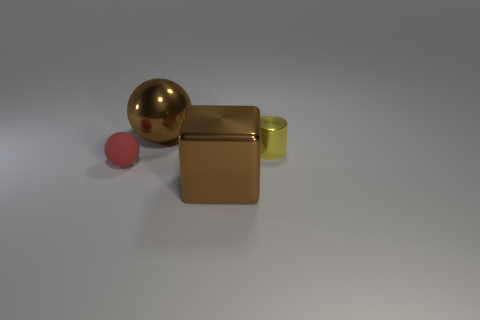What number of other objects are there of the same size as the red matte ball?
Provide a succinct answer. 1. What material is the object that is to the left of the metallic cylinder and behind the tiny red object?
Keep it short and to the point. Metal. There is a brown thing to the left of the brown block; does it have the same size as the small red ball?
Your answer should be compact. No. Is the color of the small metal object the same as the metallic sphere?
Offer a terse response. No. How many large things are both in front of the yellow object and behind the matte sphere?
Make the answer very short. 0. What number of small objects are behind the big brown thing that is right of the big brown metal object behind the red object?
Give a very brief answer. 2. What is the size of the metal thing that is the same color as the metallic cube?
Provide a short and direct response. Large. The small yellow thing is what shape?
Your answer should be very brief. Cylinder. How many other big blocks are made of the same material as the large brown cube?
Your answer should be compact. 0. What is the color of the ball that is made of the same material as the large brown cube?
Keep it short and to the point. Brown. 